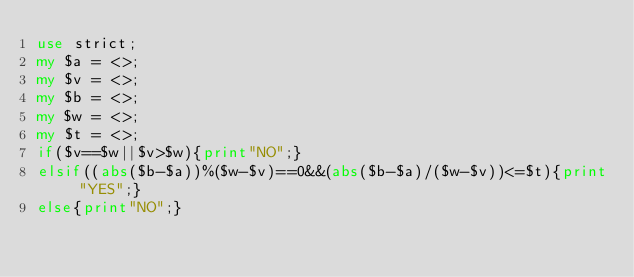Convert code to text. <code><loc_0><loc_0><loc_500><loc_500><_Perl_>use strict;
my $a = <>;
my $v = <>;
my $b = <>;
my $w = <>;
my $t = <>;
if($v==$w||$v>$w){print"NO";}
elsif((abs($b-$a))%($w-$v)==0&&(abs($b-$a)/($w-$v))<=$t){print "YES";}
else{print"NO";}</code> 